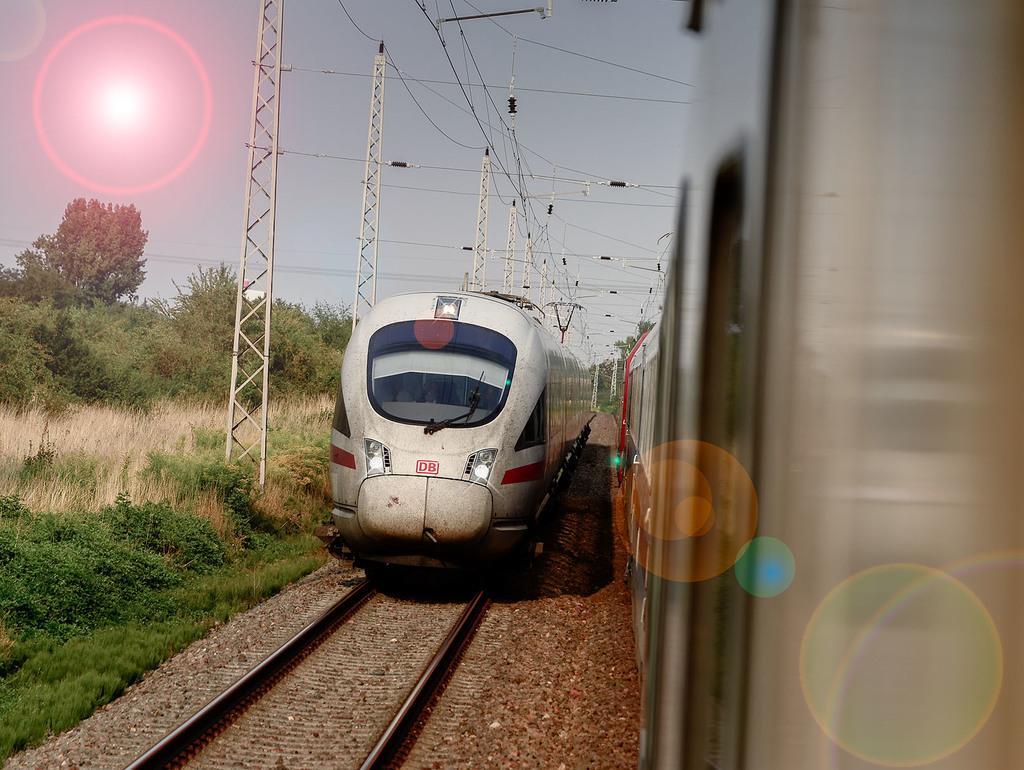How would you summarize this image in a sentence or two? In this image there is a train on the track, beside this train there is another train. On the left side of the image there are a few utility poles connected with cables, trees, plants, grass and in the background there is the sky. 